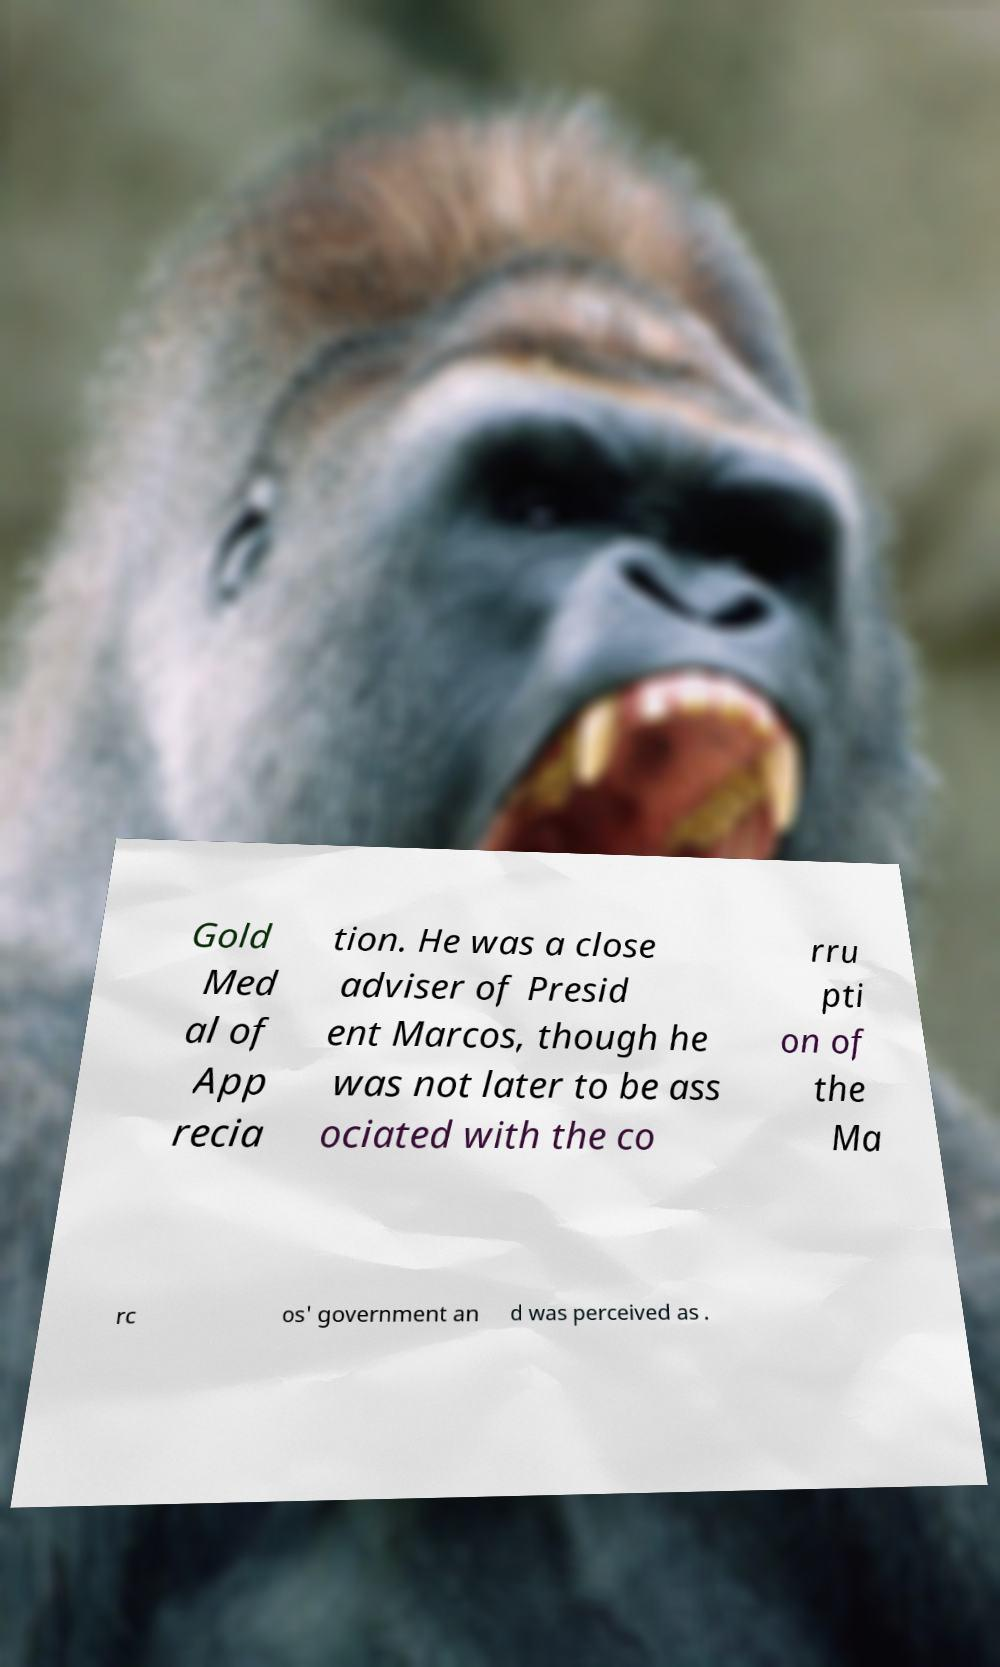For documentation purposes, I need the text within this image transcribed. Could you provide that? Gold Med al of App recia tion. He was a close adviser of Presid ent Marcos, though he was not later to be ass ociated with the co rru pti on of the Ma rc os' government an d was perceived as . 